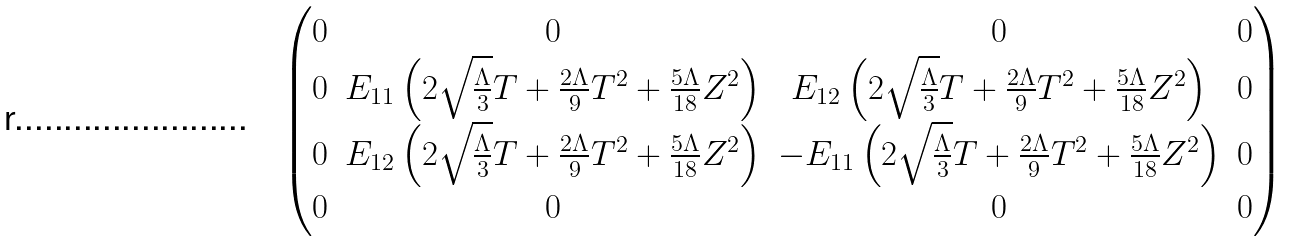<formula> <loc_0><loc_0><loc_500><loc_500>\begin{pmatrix} 0 & 0 & 0 & 0 \\ 0 & E _ { 1 1 } \left ( 2 \sqrt { \frac { \Lambda } { 3 } } T + \frac { 2 \Lambda } { 9 } T ^ { 2 } + \frac { 5 \Lambda } { 1 8 } Z ^ { 2 } \right ) & E _ { 1 2 } \left ( 2 \sqrt { \frac { \Lambda } { 3 } } T + \frac { 2 \Lambda } { 9 } T ^ { 2 } + \frac { 5 \Lambda } { 1 8 } Z ^ { 2 } \right ) & 0 \\ 0 & E _ { 1 2 } \left ( 2 \sqrt { \frac { \Lambda } { 3 } } T + \frac { 2 \Lambda } { 9 } T ^ { 2 } + \frac { 5 \Lambda } { 1 8 } Z ^ { 2 } \right ) & - E _ { 1 1 } \left ( 2 \sqrt { \frac { \Lambda } { 3 } } T + \frac { 2 \Lambda } { 9 } T ^ { 2 } + \frac { 5 \Lambda } { 1 8 } Z ^ { 2 } \right ) & 0 \\ 0 & 0 & 0 & 0 \\ \end{pmatrix}</formula> 